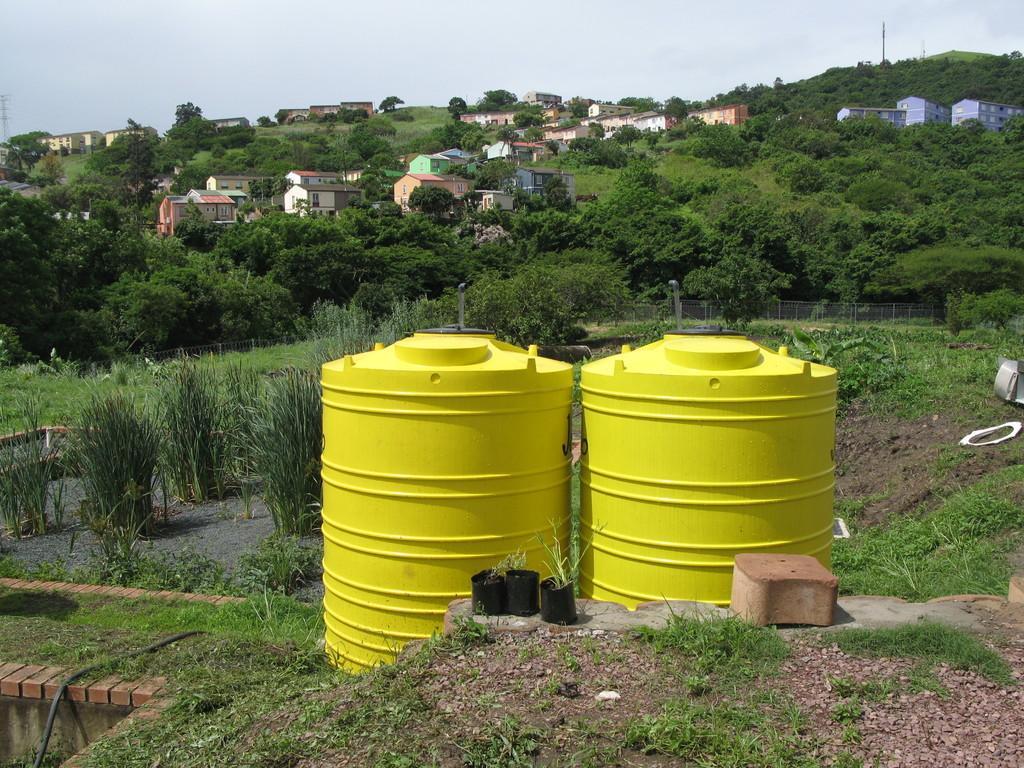How would you summarize this image in a sentence or two? In this image in the foreground there are two barrels, and at the bottom there is grass and some flower pots and tile. In the background there are some plants, railing, houses, trees, poles and at the top of the image there is sky. 